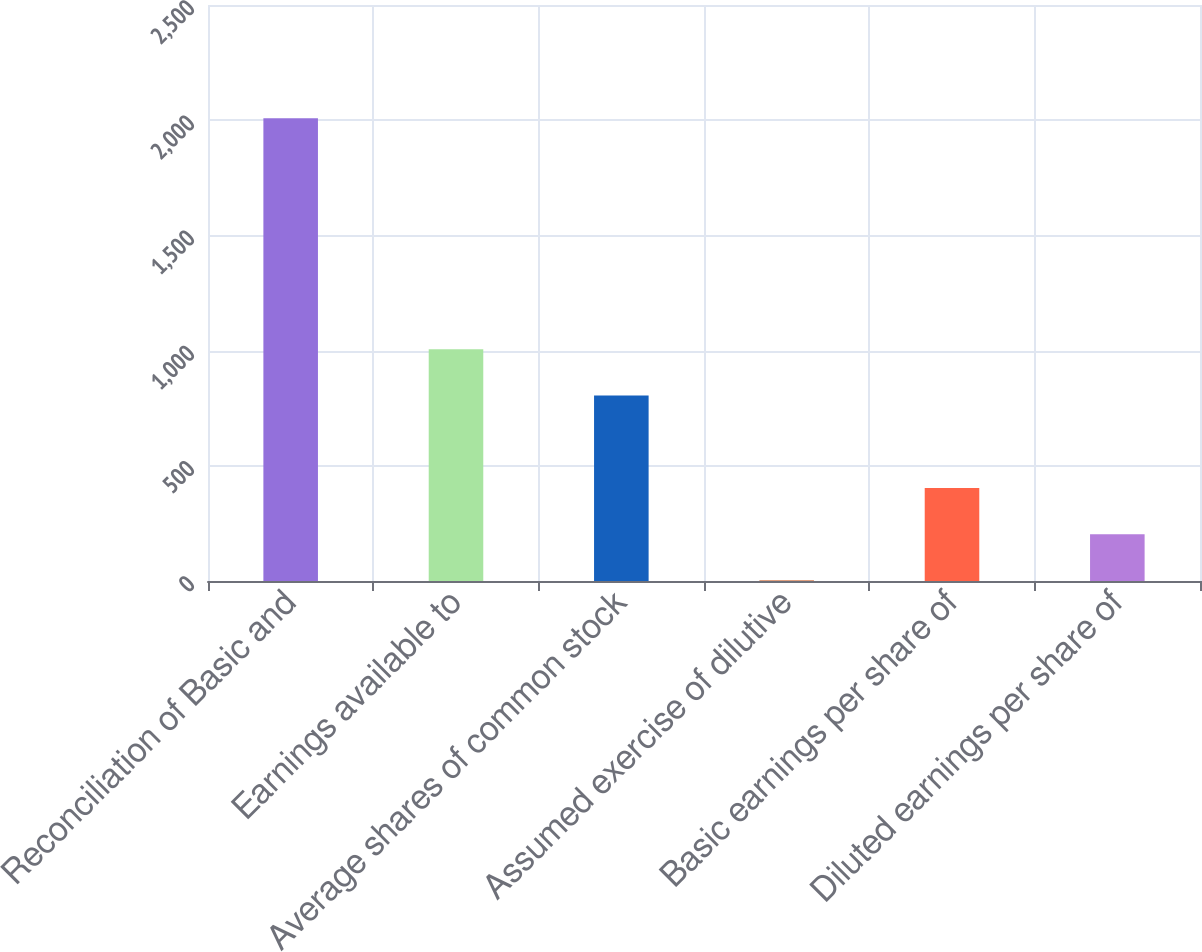Convert chart to OTSL. <chart><loc_0><loc_0><loc_500><loc_500><bar_chart><fcel>Reconciliation of Basic and<fcel>Earnings available to<fcel>Average shares of common stock<fcel>Assumed exercise of dilutive<fcel>Basic earnings per share of<fcel>Diluted earnings per share of<nl><fcel>2009<fcel>1006<fcel>804.8<fcel>2<fcel>403.4<fcel>202.7<nl></chart> 